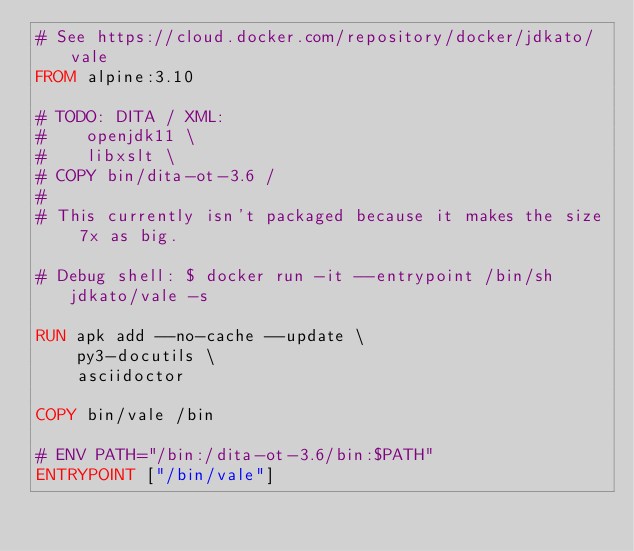<code> <loc_0><loc_0><loc_500><loc_500><_Dockerfile_># See https://cloud.docker.com/repository/docker/jdkato/vale
FROM alpine:3.10

# TODO: DITA / XML:
#    openjdk11 \
#    libxslt \
# COPY bin/dita-ot-3.6 /
#
# This currently isn't packaged because it makes the size 7x as big.

# Debug shell: $ docker run -it --entrypoint /bin/sh jdkato/vale -s

RUN apk add --no-cache --update \
    py3-docutils \
    asciidoctor

COPY bin/vale /bin

# ENV PATH="/bin:/dita-ot-3.6/bin:$PATH"
ENTRYPOINT ["/bin/vale"]
</code> 